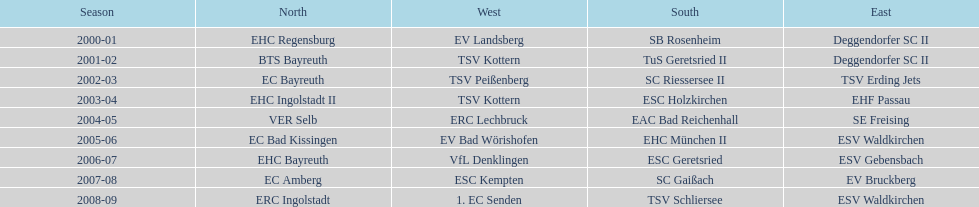Which name appears more often, kottern or bayreuth? Bayreuth. 